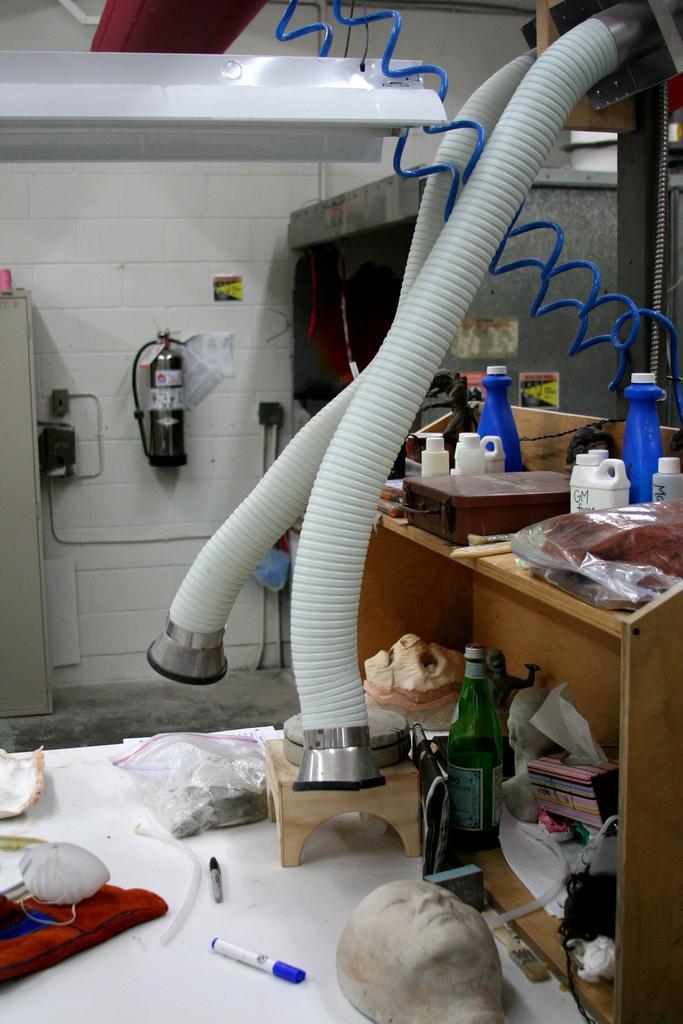Could you give a brief overview of what you see in this image? This is looks like an exhaust pipe of a device. This is a wooden table where a bottle, a box and covers are kept on it. Under the table there is a wine bottle and clothes. We can see a sketch pen , a cloth and a face mask on the floor. 